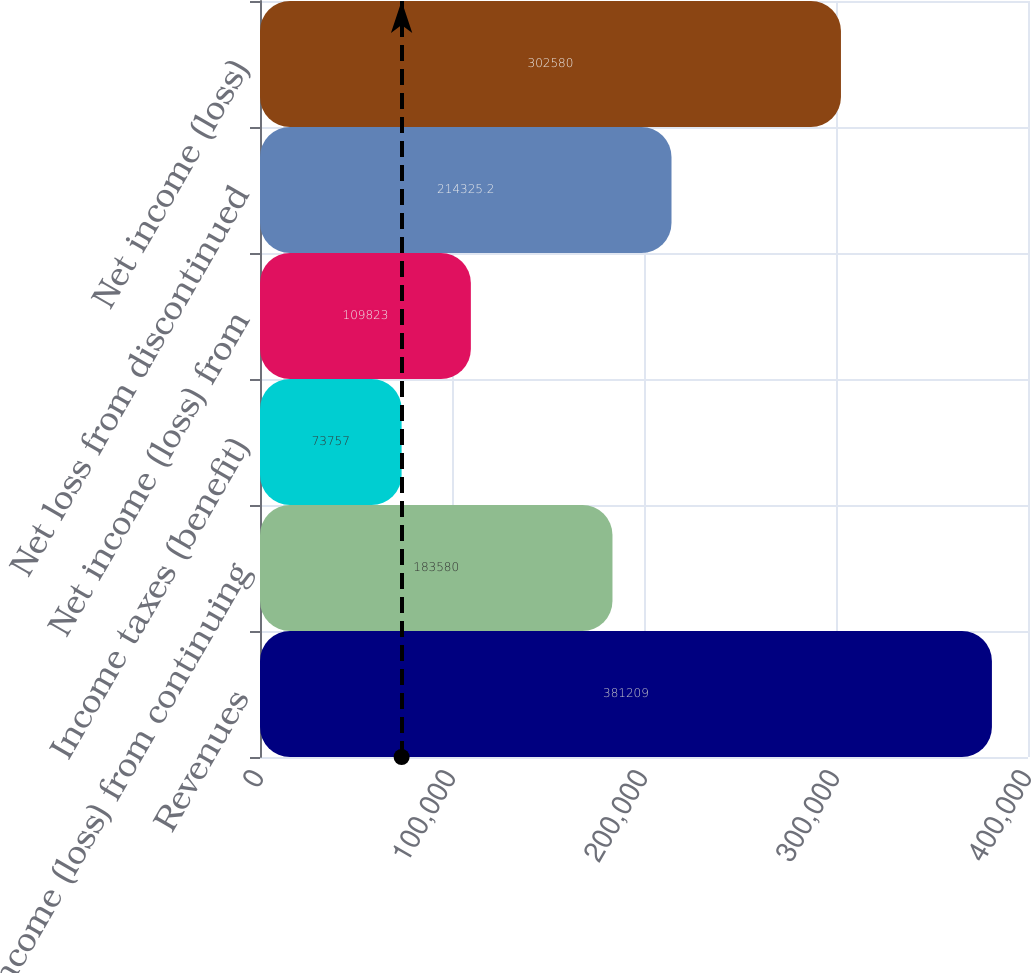Convert chart to OTSL. <chart><loc_0><loc_0><loc_500><loc_500><bar_chart><fcel>Revenues<fcel>Income (loss) from continuing<fcel>Income taxes (benefit)<fcel>Net income (loss) from<fcel>Net loss from discontinued<fcel>Net income (loss)<nl><fcel>381209<fcel>183580<fcel>73757<fcel>109823<fcel>214325<fcel>302580<nl></chart> 